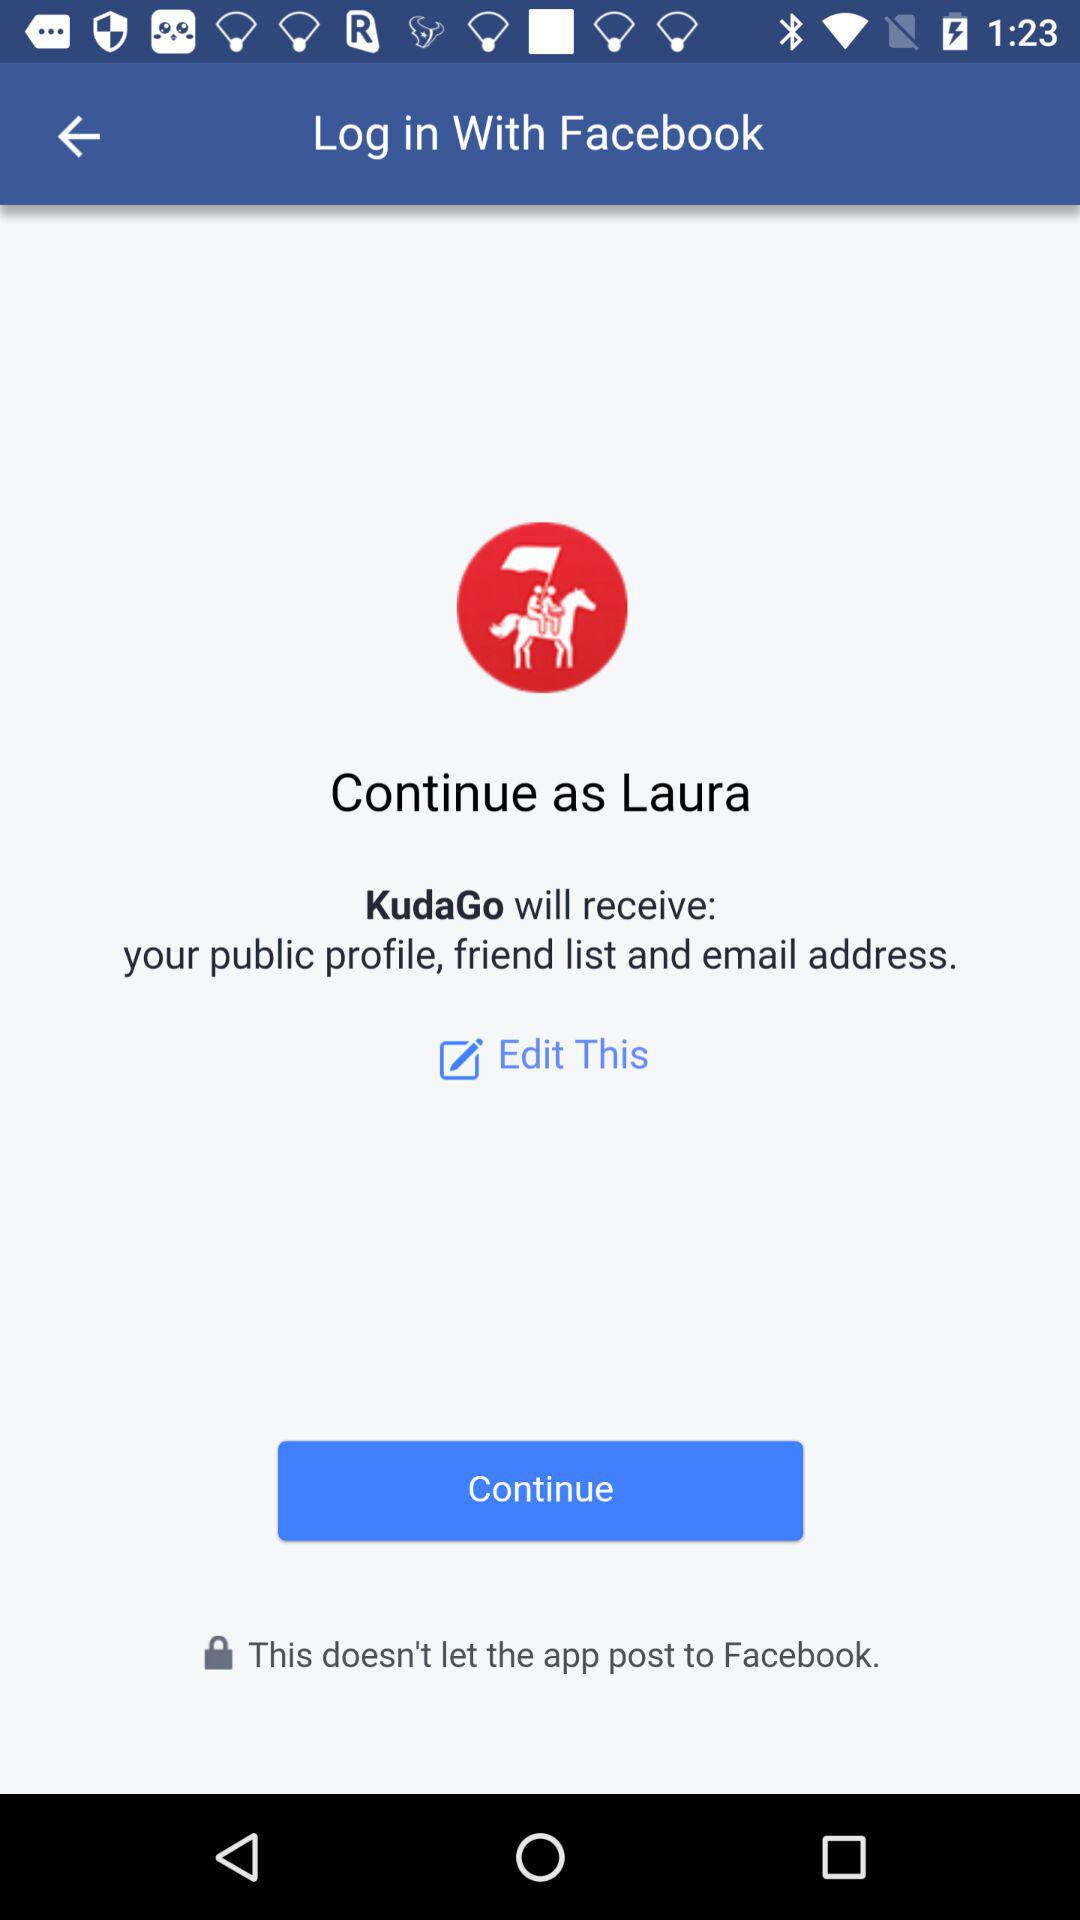Which information will "KudaGo" receive? "KudaGo" will receive your public profile, friend list and email address. 